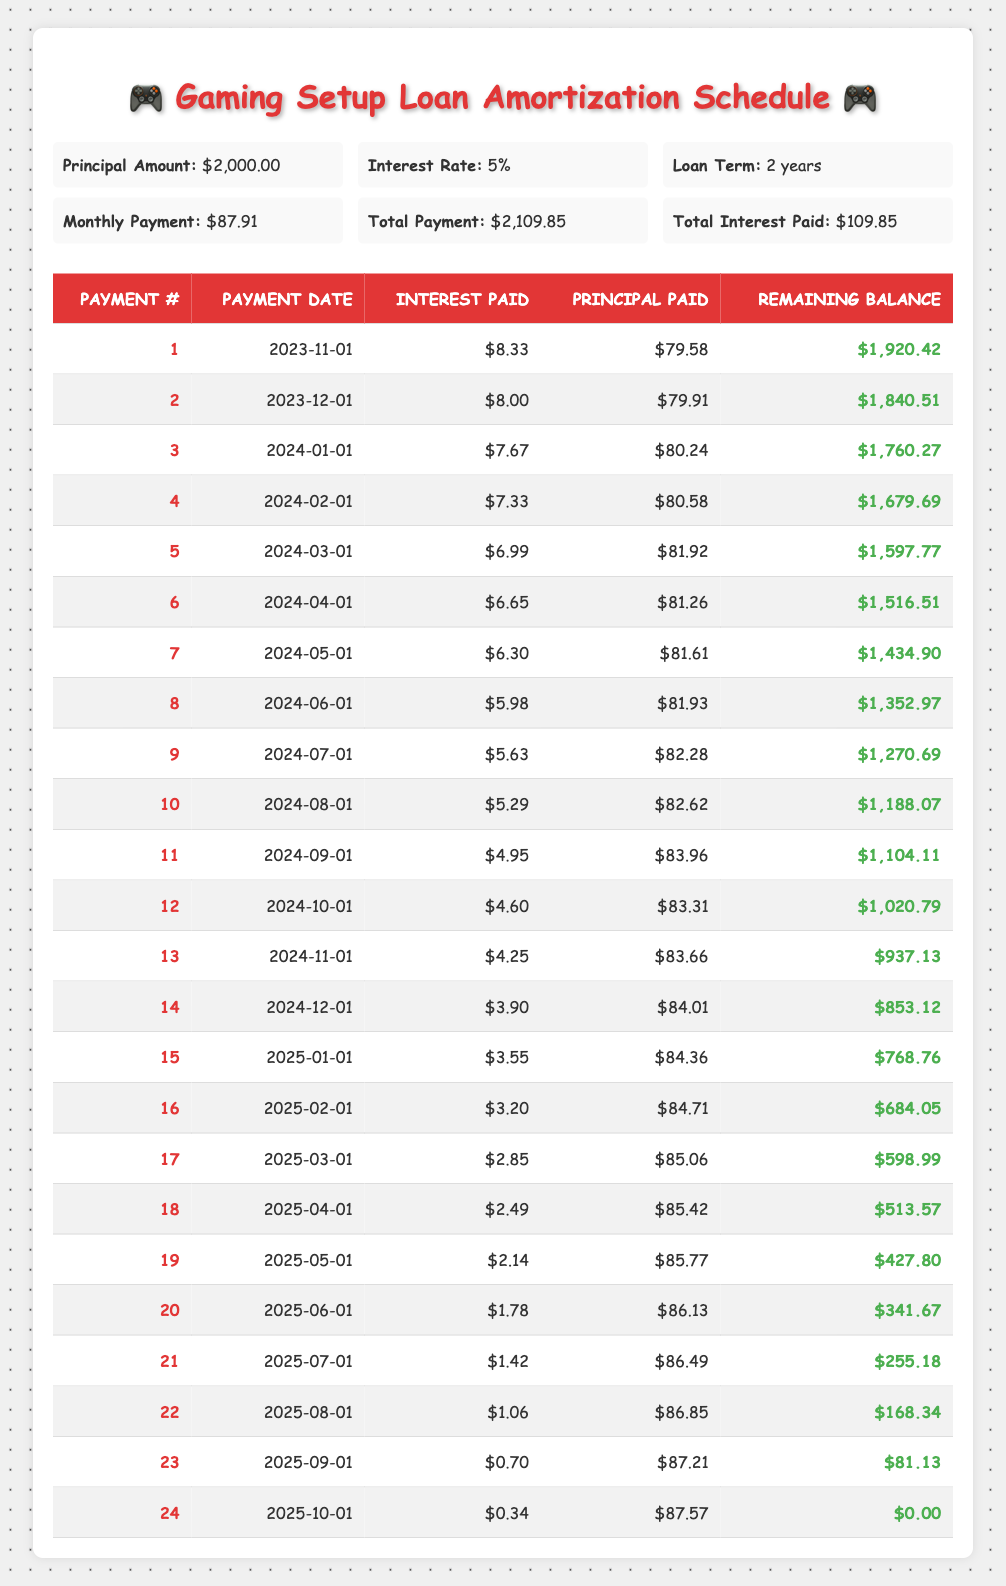What is the total principal paid by the end of the loan? To find the total principal paid, we need to sum the "Principal Paid" column from each payment. The total principal paid over 24 payments is: 79.58 + 79.91 + 80.24 + 80.58 + 81.92 + 81.26 + 81.61 + 81.93 + 82.28 + 82.62 + 83.96 + 83.31 + 83.66 + 84.01 + 84.36 + 84.71 + 85.06 + 85.42 + 85.77 + 86.13 + 86.49 + 86.85 + 87.21 + 87.57 = 2000
Answer: 2000 What is the highest interest payment made in a month? By examining the "Interest Paid" column, the values are: 8.33, 8.00, 7.67, 7.33, 6.99, 6.65, 6.30, 5.98, 5.63, 5.29, 4.95, 4.60, 4.25, 3.90, 3.55, 3.20, 2.85, 2.49, 2.14, 1.78, 1.42, 1.06, 0.70, 0.34. The highest value is 8.33.
Answer: 8.33 What is the total interest paid by the end of the loan? The total interest paid is provided directly in the loan details section. It states that the "Total Interest Paid" is $109.85.
Answer: 109.85 Is the monthly payment consistent throughout the loan term? By looking at the "Monthly Payment," it is constant at $87.91 for all 24 payments, indicating that the monthly payment does not change.
Answer: Yes What was the remaining balance after the 12th payment? Checking the "Remaining Balance" column, after the 12th payment, the remaining balance is listed as $1,020.79.
Answer: $1,020.79 What is the difference between the first and last interest payments? The first interest payment is 8.33 and the last interest payment is 0.34. To find the difference, we subtract the last from the first: 8.33 - 0.34 = 7.99.
Answer: 7.99 How much was the principal paid in the last payment? Looking at the last row of the table under "Principal Paid," it shows that the principal paid in the last payment is $87.57.
Answer: 87.57 What was the average amount of interest paid per month? To find the average interest paid, we sum all interest payments: (8.33 + 8.00 + 7.67 + 7.33 + 6.99 + 6.65 + 6.30 + 5.98 + 5.63 + 5.29 + 4.95 + 4.60 + 4.25 + 3.90 + 3.55 + 3.20 + 2.85 + 2.49 + 2.14 + 1.78 + 1.42 + 1.06 + 0.70 + 0.34) = 70.42. The average is then 70.42/24 ≈ 2.935.
Answer: 2.935 How much principal is left after 6 months? The table shows the remaining balance after the 6th payment as $1,516.51. This means $1,516.51 is left to pay after 6 months.
Answer: $1,516.51 